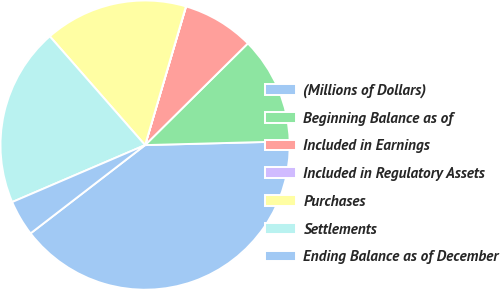Convert chart to OTSL. <chart><loc_0><loc_0><loc_500><loc_500><pie_chart><fcel>(Millions of Dollars)<fcel>Beginning Balance as of<fcel>Included in Earnings<fcel>Included in Regulatory Assets<fcel>Purchases<fcel>Settlements<fcel>Ending Balance as of December<nl><fcel>39.96%<fcel>12.0%<fcel>8.01%<fcel>0.02%<fcel>16.0%<fcel>19.99%<fcel>4.01%<nl></chart> 